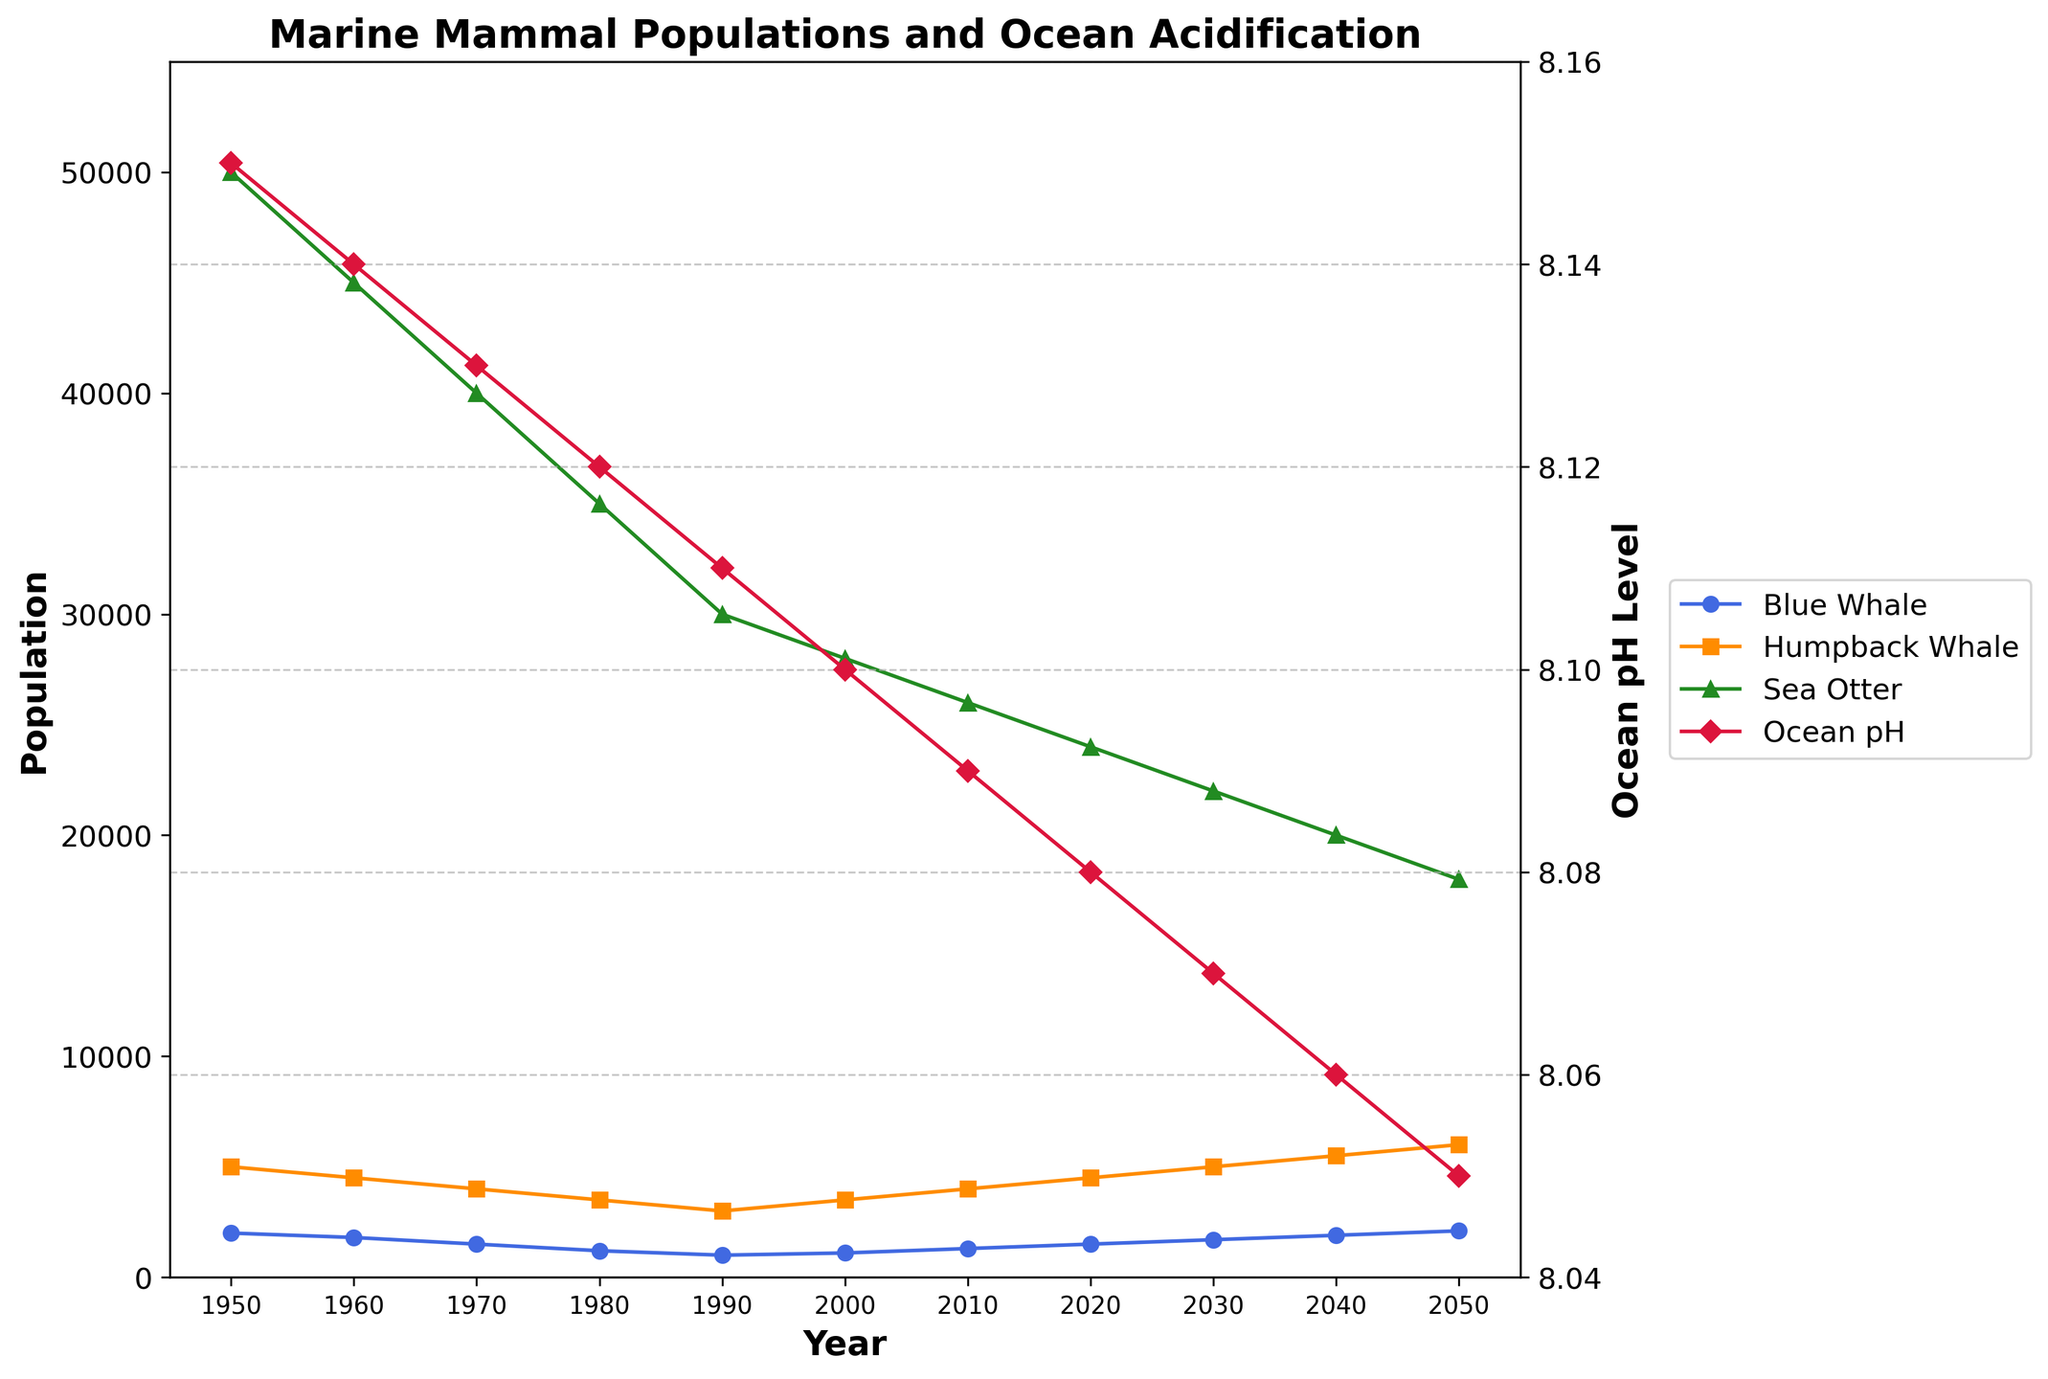What is the population difference between Blue Whales and Humpback Whales in the year 2000? In the year 2000, the population of Blue Whales is 1100 and Humpback Whales is 3500. The difference is calculated as 3500 - 1100 = 2400.
Answer: 2400 How does the population of Sea Otters in 1950 compare to 2020? In 1950, the Sea Otter population is 50000 and in 2020, it is 24000. The decrease is 50000 - 24000 = 26000.
Answer: Decreases by 26000 What is the trend of Ocean pH Level from 1950 to 2050? The Ocean pH Level consistently decreases from 8.15 in 1950 to 8.05 in 2050.
Answer: Decreasing trend Which year shows the lowest Blue Whale population and what was the pH level at that time? The lowest Blue Whale population is in 1990, with 1000 individuals, and the corresponding Ocean pH Level was 8.11.
Answer: 1990, 8.11 In which year did the Sea Otter population first fall below 30000? The first year the Sea Otter population falls below 30000 is 2000, with 28000 individuals.
Answer: 2000 How does the population trend of Humpback Whales compare to Blue Whales from 2000 to 2050? From 2000 to 2050, both Humpback Whales and Blue Whales populations increase. However, Humpback Whale population increases from 3500 to 6000 whereas the Blue Whale population increases from 1100 to 2100, showing a larger increase in Humpback Whales.
Answer: Humpback Whales increase more Calculate the average Ocean pH Level between the years 1950 and 2050. The Ocean pH Levels are: 8.15, 8.14, 8.13, 8.12, 8.11, 8.10, 8.09, 8.08, 8.07, 8.06, 8.05. Sum these values: 8.15 + 8.14 + 8.13 + 8.12 + 8.11 + 8.10 + 8.09 + 8.08 + 8.07 + 8.06 + 8.05 = 89.10. There are 11 data points. Average = 89.10 / 11 = 8.10.
Answer: 8.10 What is the overall change in the Sea Otter population from 1950 to 2050? In 1950, the Sea Otter population is 50000, and by 2050, it is 18000. The change is 50000 - 18000 = 32000.
Answer: Decrease by 32000 